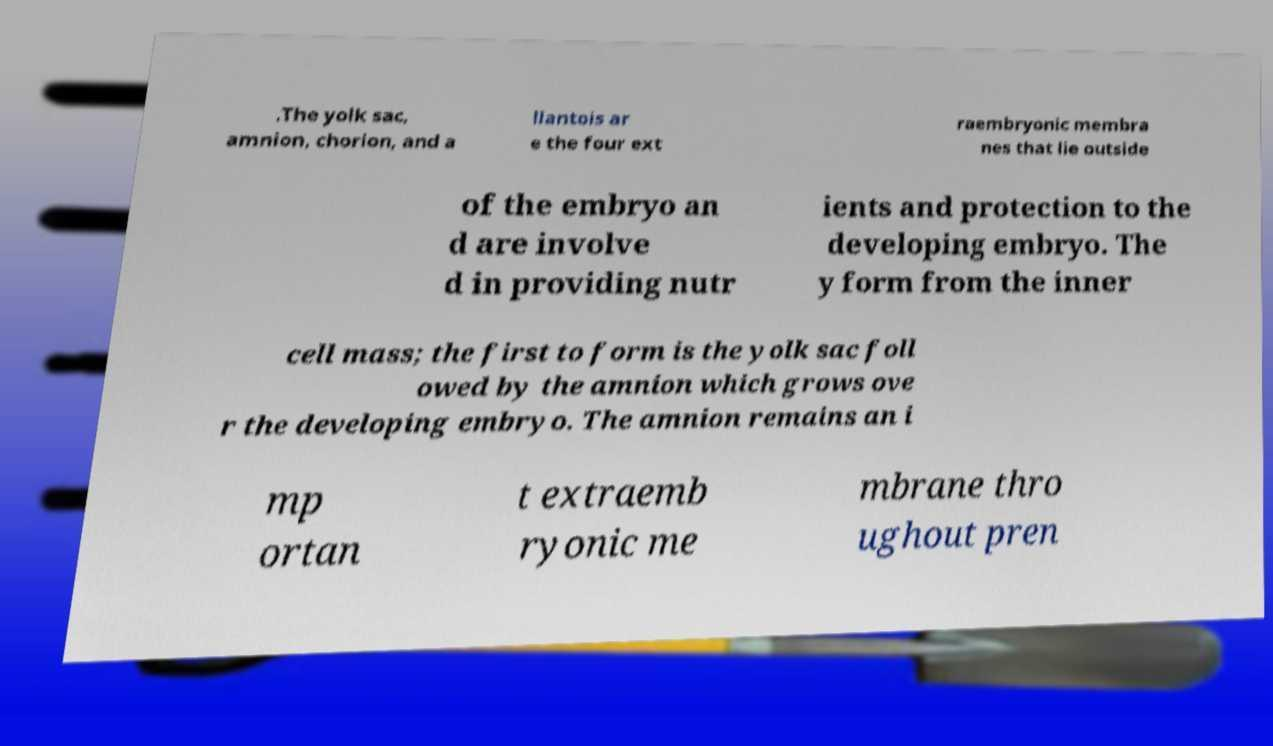Please identify and transcribe the text found in this image. .The yolk sac, amnion, chorion, and a llantois ar e the four ext raembryonic membra nes that lie outside of the embryo an d are involve d in providing nutr ients and protection to the developing embryo. The y form from the inner cell mass; the first to form is the yolk sac foll owed by the amnion which grows ove r the developing embryo. The amnion remains an i mp ortan t extraemb ryonic me mbrane thro ughout pren 